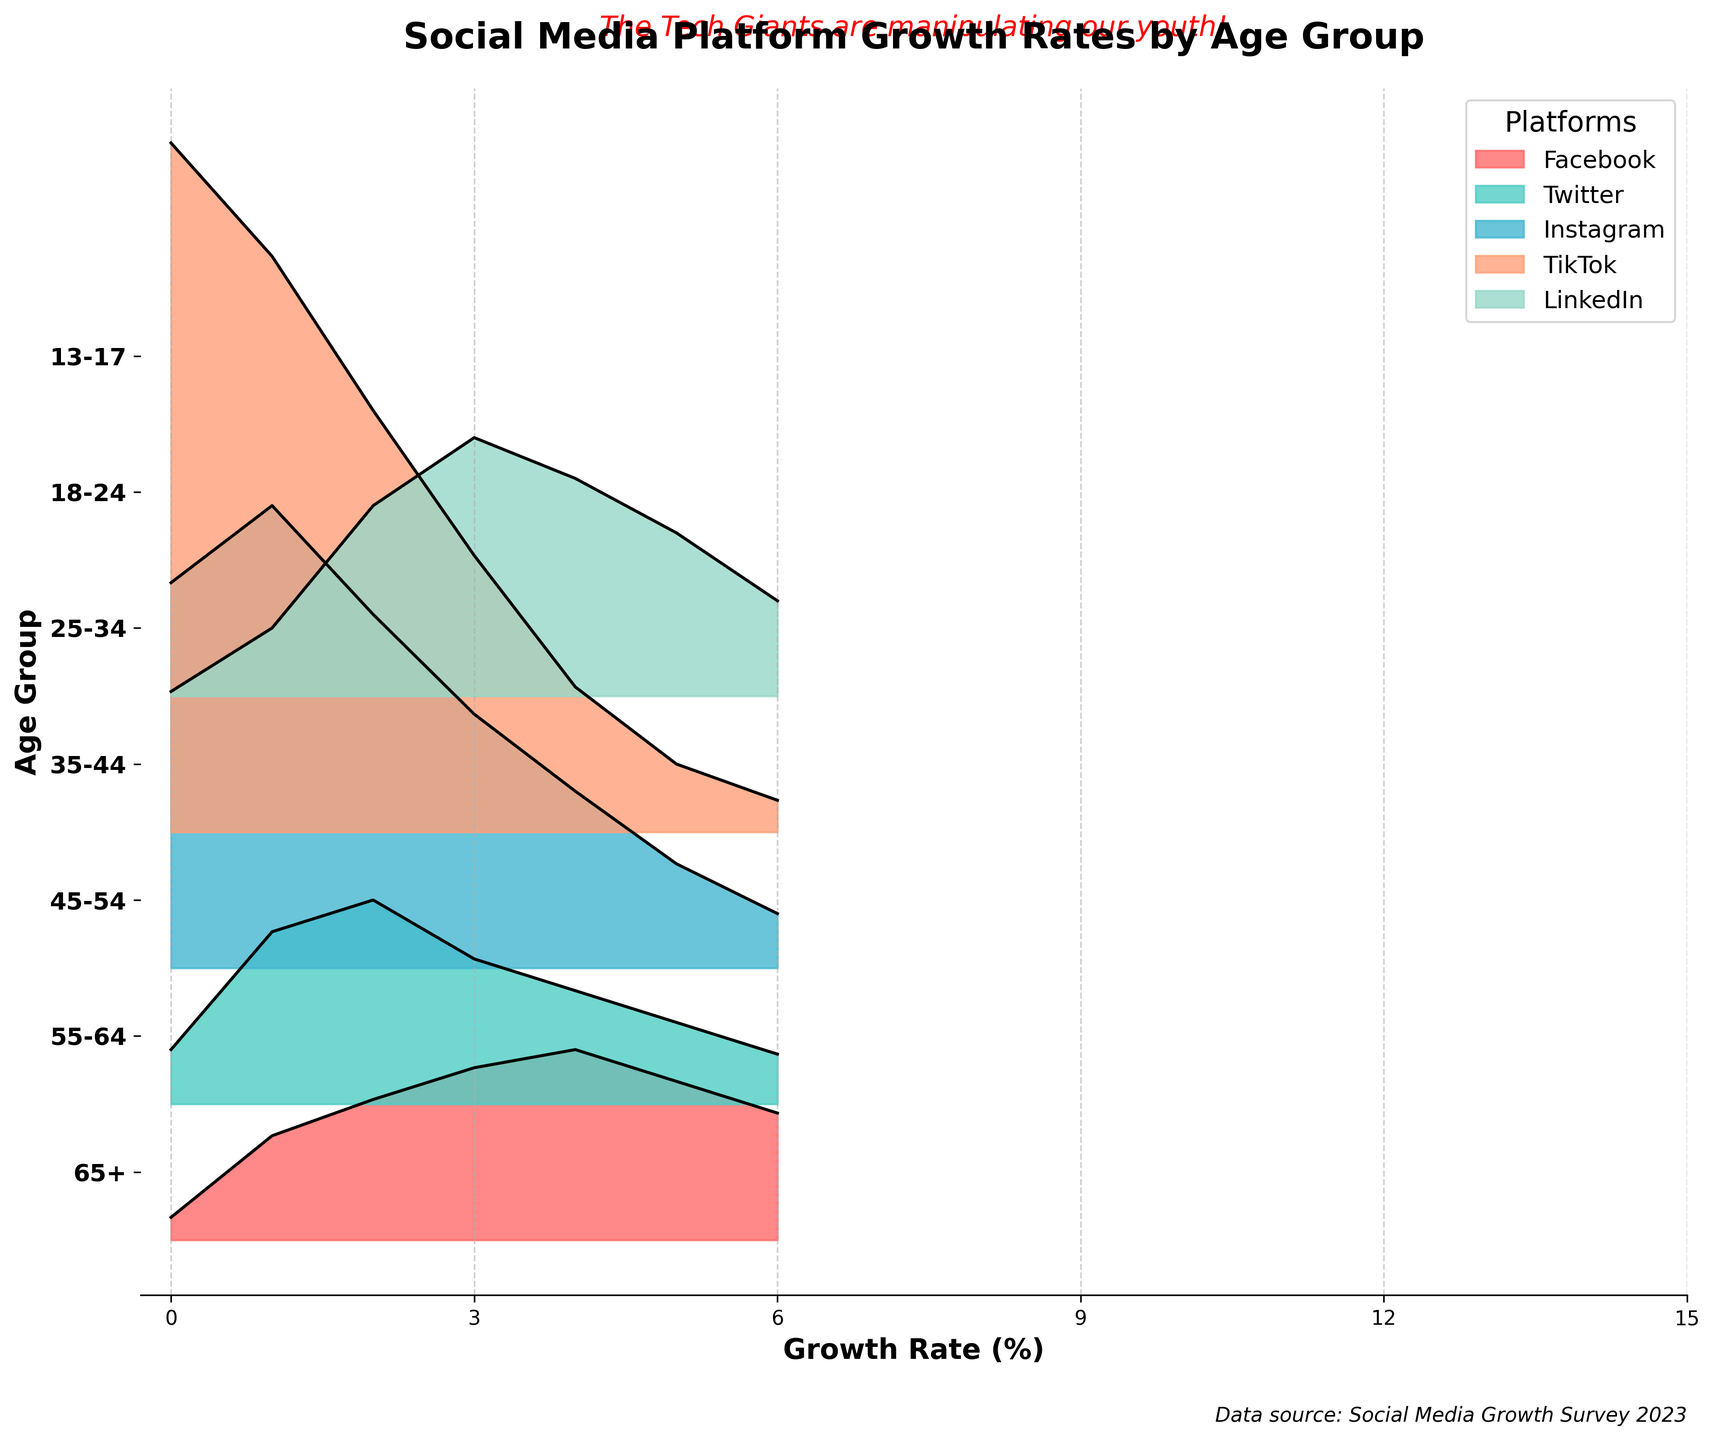What is the title of the plot? The title is the text at the top of the plot.
Answer: Social Media Platform Growth Rates by Age Group Which age group has the highest growth rate for TikTok? Look at the highest point of the TikTok curve to identify the age group.
Answer: 13-17 What is the growth rate of Instagram for the 25-34 age group? Locate the respective age group on the y-axis and trace the Instagram line to find the growth rate.
Answer: 7.8% Which platform has the smallest growth rate for the 18-24 age group? Identify the lowest line for the 18-24 age group among all platforms.
Answer: LinkedIn How does TikTok's growth rate trend change from the 13-17 age group to the 65+ age group? Observe the heights of the TikTok sections for each age group from 13-17 to 65+.
Answer: Decreasing Which platform shows a noticeable increase in growth rate from the 18-24 to 25-34 age group? Compare the heights of each platform's line between 18-24 and 25-34 age groups.
Answer: Facebook Are there any age groups where Facebook's growth rate is higher than Instagram's? Compare the heights of Facebook and Instagram lines per age group to find overlaps.
Answer: Yes, 35-44, 45-54, 55-64, 65+ How many platforms have their highest growth rate in the 13-17 age group? Count the number of platforms peaking in the 13-17 age group.
Answer: Two (Instagram and TikTok) For the 45-54 age group, which platform has the highest growth rate? Locate the 45-54 age group on the y-axis and identify the tallest platform line.
Answer: Facebook What is the average growth rate of Twitter across all age groups? Sum Twitter's growth rates across all age groups and divide by the number of groups.
Answer: 2.72% 